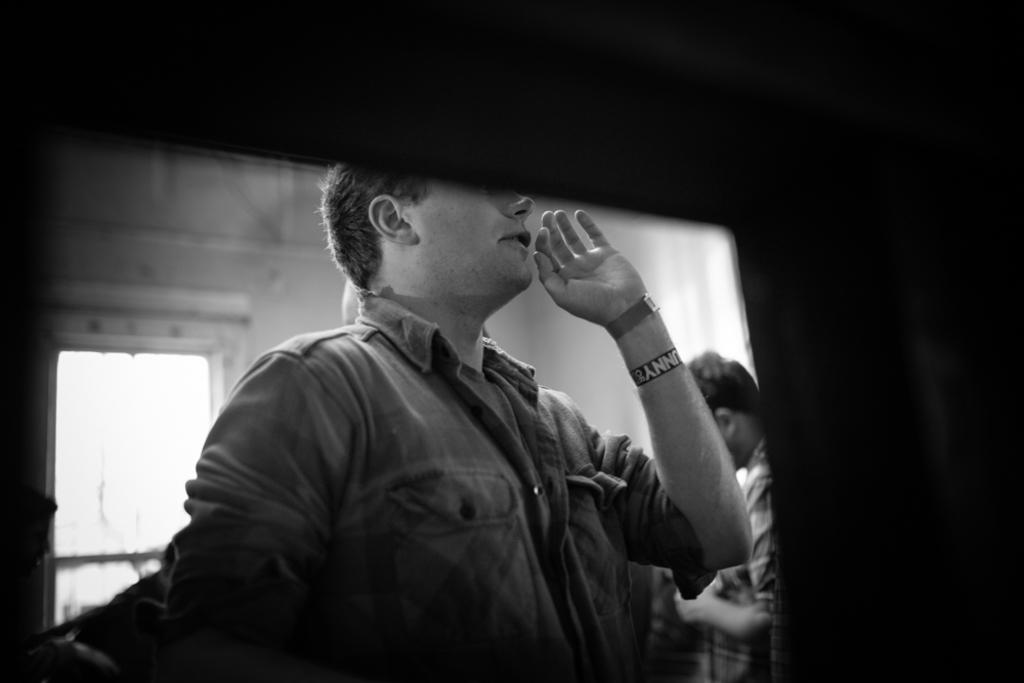How many people are in the image? There are two persons in the image. What can be seen near the persons? There is an entrance gate in the image. What type of structure is visible in the image? There is a wall visible in the image. What is the color of the background in the image? The background of the image is dark. What type of bed can be seen in the image? There is no bed present in the image. How many hands are visible in the image? The number of hands visible in the image cannot be determined from the provided facts. 